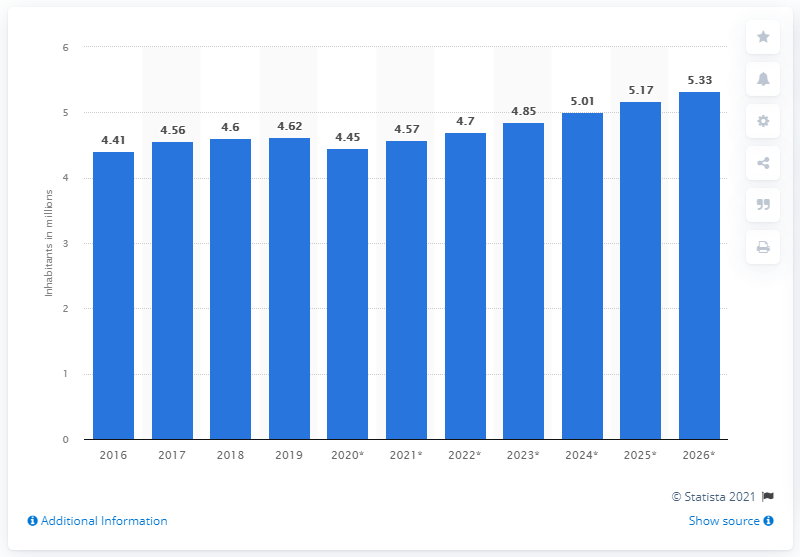Give some essential details in this illustration. In 2019, the population of Oman was 4.62 million. 